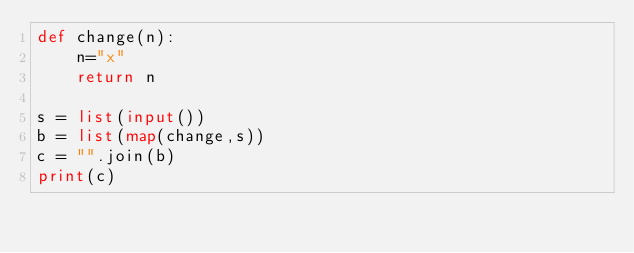Convert code to text. <code><loc_0><loc_0><loc_500><loc_500><_Python_>def change(n):
    n="x"
    return n

s = list(input())
b = list(map(change,s))
c = "".join(b)
print(c)</code> 